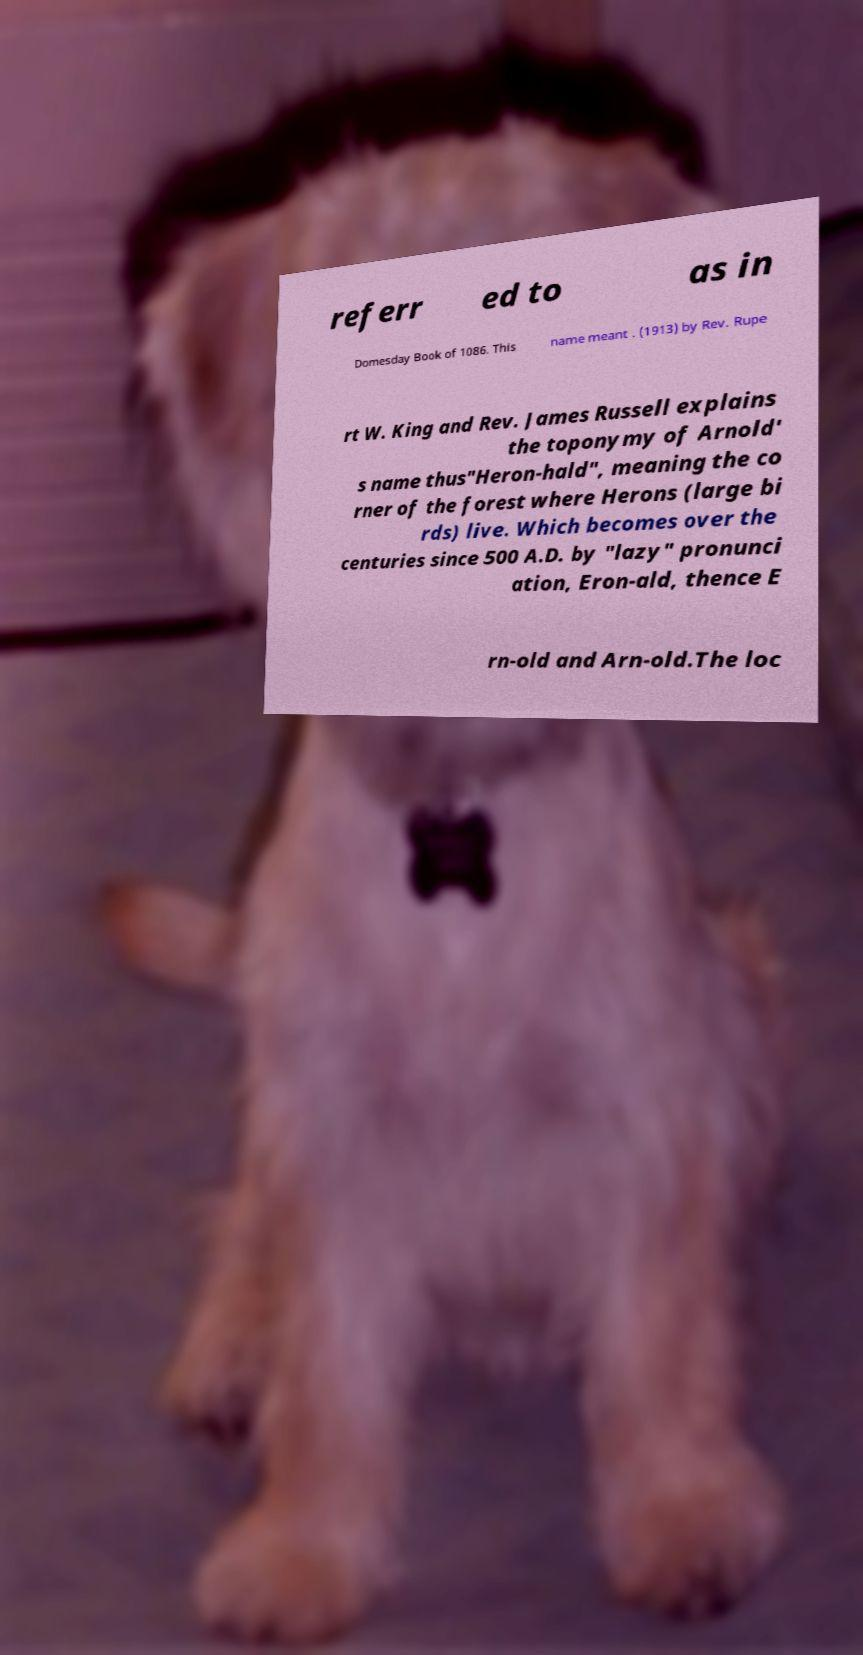Can you read and provide the text displayed in the image?This photo seems to have some interesting text. Can you extract and type it out for me? referr ed to as in Domesday Book of 1086. This name meant . (1913) by Rev. Rupe rt W. King and Rev. James Russell explains the toponymy of Arnold' s name thus"Heron-hald", meaning the co rner of the forest where Herons (large bi rds) live. Which becomes over the centuries since 500 A.D. by "lazy" pronunci ation, Eron-ald, thence E rn-old and Arn-old.The loc 